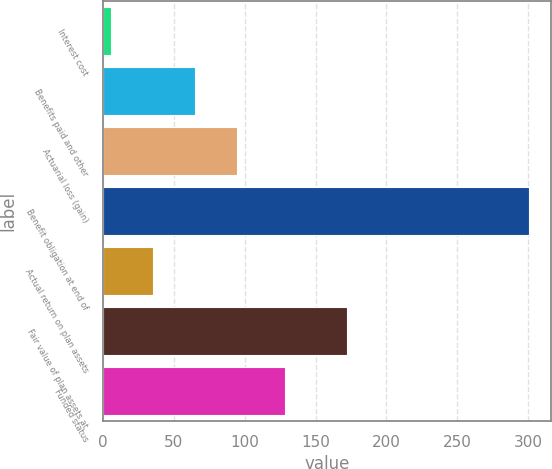<chart> <loc_0><loc_0><loc_500><loc_500><bar_chart><fcel>Interest cost<fcel>Benefits paid and other<fcel>Actuarial loss (gain)<fcel>Benefit obligation at end of<fcel>Actual return on plan assets<fcel>Fair value of plan assets at<fcel>Funded status<nl><fcel>5.8<fcel>64.8<fcel>94.3<fcel>300.8<fcel>35.3<fcel>172.2<fcel>128.6<nl></chart> 